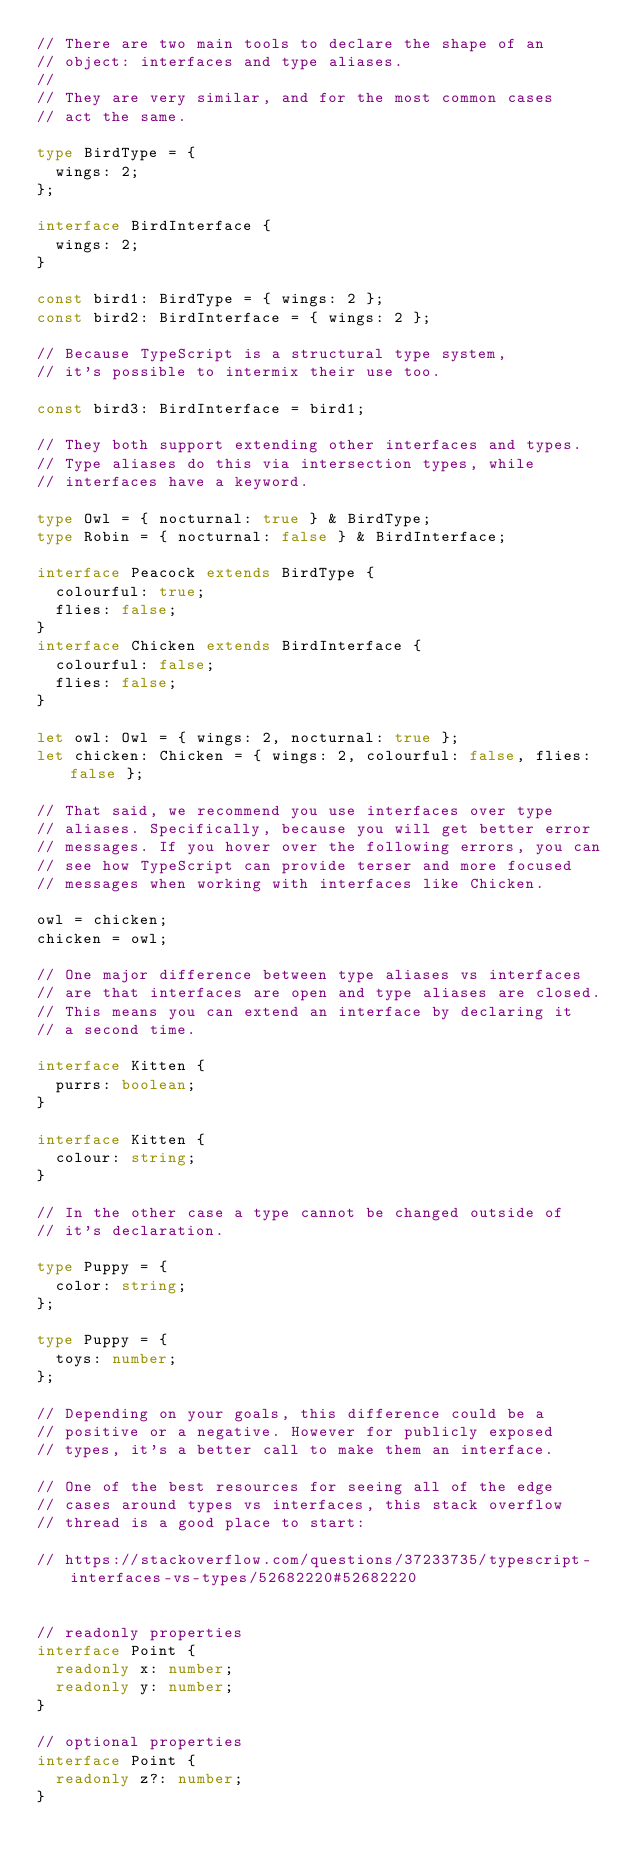Convert code to text. <code><loc_0><loc_0><loc_500><loc_500><_TypeScript_>// There are two main tools to declare the shape of an
// object: interfaces and type aliases.
//
// They are very similar, and for the most common cases
// act the same.

type BirdType = {
  wings: 2;
};

interface BirdInterface {
  wings: 2;
}

const bird1: BirdType = { wings: 2 };
const bird2: BirdInterface = { wings: 2 };

// Because TypeScript is a structural type system,
// it's possible to intermix their use too.

const bird3: BirdInterface = bird1;

// They both support extending other interfaces and types.
// Type aliases do this via intersection types, while
// interfaces have a keyword.

type Owl = { nocturnal: true } & BirdType;
type Robin = { nocturnal: false } & BirdInterface;

interface Peacock extends BirdType {
  colourful: true;
  flies: false;
}
interface Chicken extends BirdInterface {
  colourful: false;
  flies: false;
}

let owl: Owl = { wings: 2, nocturnal: true };
let chicken: Chicken = { wings: 2, colourful: false, flies: false };

// That said, we recommend you use interfaces over type
// aliases. Specifically, because you will get better error
// messages. If you hover over the following errors, you can
// see how TypeScript can provide terser and more focused
// messages when working with interfaces like Chicken.

owl = chicken;
chicken = owl;

// One major difference between type aliases vs interfaces
// are that interfaces are open and type aliases are closed.
// This means you can extend an interface by declaring it
// a second time.

interface Kitten {
  purrs: boolean;
}

interface Kitten {
  colour: string;
}

// In the other case a type cannot be changed outside of
// it's declaration.

type Puppy = {
  color: string;
};

type Puppy = {
  toys: number;
};

// Depending on your goals, this difference could be a
// positive or a negative. However for publicly exposed
// types, it's a better call to make them an interface.

// One of the best resources for seeing all of the edge
// cases around types vs interfaces, this stack overflow
// thread is a good place to start:

// https://stackoverflow.com/questions/37233735/typescript-interfaces-vs-types/52682220#52682220


// readonly properties
interface Point {
  readonly x: number;
  readonly y: number;
}

// optional properties
interface Point {
  readonly z?: number;
}
</code> 